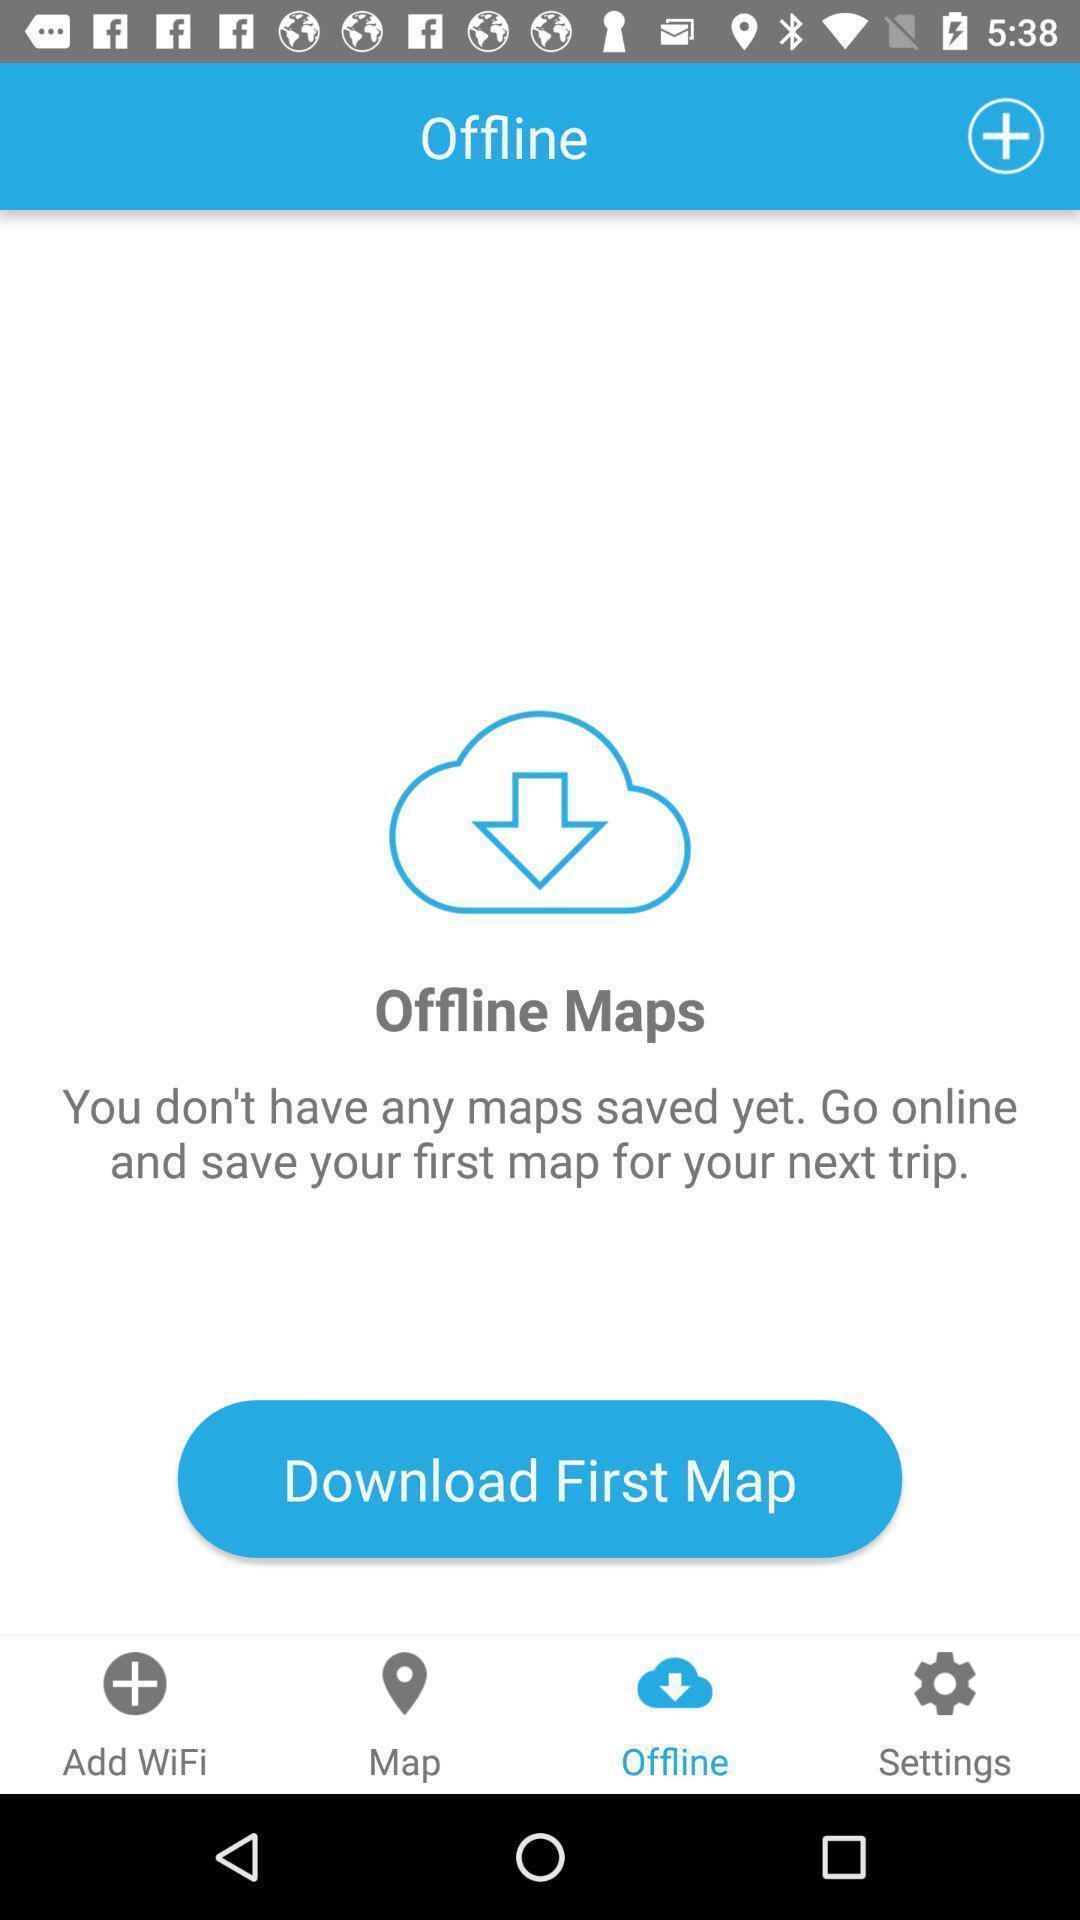Describe the key features of this screenshot. Page displaying for location finder app. 